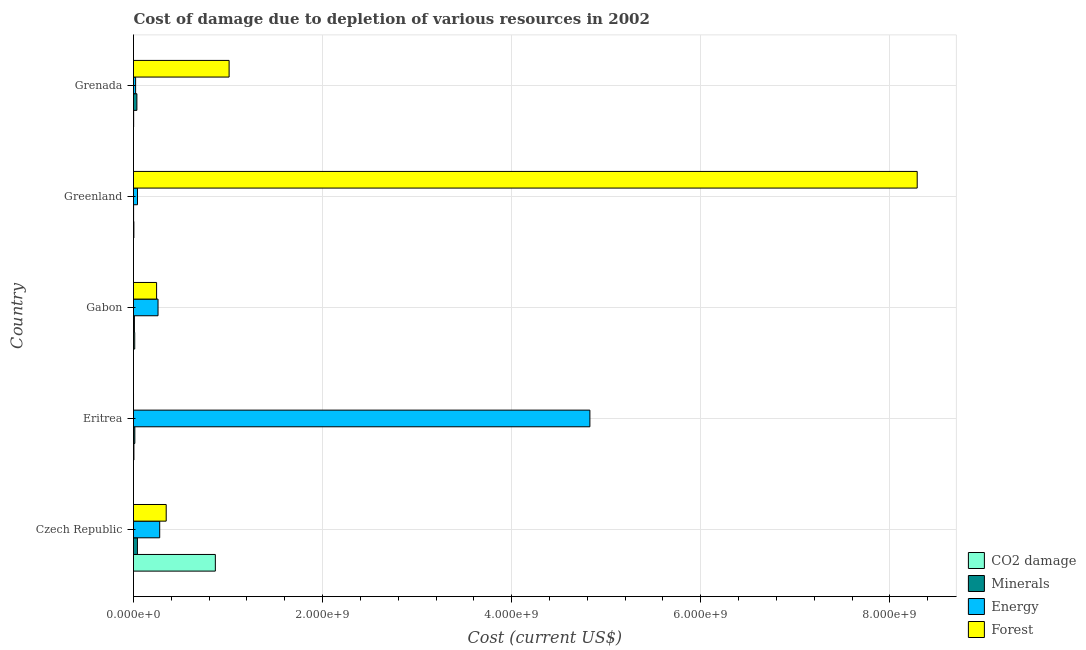How many groups of bars are there?
Provide a short and direct response. 5. Are the number of bars per tick equal to the number of legend labels?
Your answer should be compact. Yes. Are the number of bars on each tick of the Y-axis equal?
Give a very brief answer. Yes. What is the label of the 4th group of bars from the top?
Offer a very short reply. Eritrea. What is the cost of damage due to depletion of energy in Eritrea?
Ensure brevity in your answer.  4.83e+09. Across all countries, what is the maximum cost of damage due to depletion of energy?
Provide a succinct answer. 4.83e+09. Across all countries, what is the minimum cost of damage due to depletion of minerals?
Ensure brevity in your answer.  8.50e+05. In which country was the cost of damage due to depletion of forests maximum?
Your response must be concise. Greenland. In which country was the cost of damage due to depletion of minerals minimum?
Your answer should be compact. Greenland. What is the total cost of damage due to depletion of forests in the graph?
Provide a short and direct response. 9.89e+09. What is the difference between the cost of damage due to depletion of forests in Gabon and that in Grenada?
Offer a very short reply. -7.67e+08. What is the difference between the cost of damage due to depletion of minerals in Grenada and the cost of damage due to depletion of coal in Eritrea?
Your answer should be compact. 3.14e+07. What is the average cost of damage due to depletion of minerals per country?
Give a very brief answer. 2.03e+07. What is the difference between the cost of damage due to depletion of forests and cost of damage due to depletion of minerals in Greenland?
Your answer should be compact. 8.29e+09. What is the ratio of the cost of damage due to depletion of forests in Czech Republic to that in Grenada?
Your answer should be very brief. 0.34. What is the difference between the highest and the second highest cost of damage due to depletion of forests?
Offer a very short reply. 7.28e+09. What is the difference between the highest and the lowest cost of damage due to depletion of forests?
Your answer should be compact. 8.29e+09. In how many countries, is the cost of damage due to depletion of forests greater than the average cost of damage due to depletion of forests taken over all countries?
Keep it short and to the point. 1. Is it the case that in every country, the sum of the cost of damage due to depletion of coal and cost of damage due to depletion of energy is greater than the sum of cost of damage due to depletion of minerals and cost of damage due to depletion of forests?
Give a very brief answer. No. What does the 2nd bar from the top in Eritrea represents?
Your answer should be compact. Energy. What does the 1st bar from the bottom in Czech Republic represents?
Offer a terse response. CO2 damage. How many bars are there?
Give a very brief answer. 20. How many countries are there in the graph?
Provide a short and direct response. 5. Does the graph contain any zero values?
Keep it short and to the point. No. Where does the legend appear in the graph?
Provide a short and direct response. Bottom right. How many legend labels are there?
Offer a terse response. 4. How are the legend labels stacked?
Your answer should be compact. Vertical. What is the title of the graph?
Provide a short and direct response. Cost of damage due to depletion of various resources in 2002 . What is the label or title of the X-axis?
Keep it short and to the point. Cost (current US$). What is the label or title of the Y-axis?
Provide a short and direct response. Country. What is the Cost (current US$) of CO2 damage in Czech Republic?
Provide a short and direct response. 8.66e+08. What is the Cost (current US$) of Minerals in Czech Republic?
Offer a terse response. 4.16e+07. What is the Cost (current US$) of Energy in Czech Republic?
Provide a succinct answer. 2.77e+08. What is the Cost (current US$) in Forest in Czech Republic?
Keep it short and to the point. 3.46e+08. What is the Cost (current US$) of CO2 damage in Eritrea?
Provide a succinct answer. 4.38e+06. What is the Cost (current US$) in Minerals in Eritrea?
Make the answer very short. 1.40e+07. What is the Cost (current US$) in Energy in Eritrea?
Make the answer very short. 4.83e+09. What is the Cost (current US$) in Forest in Eritrea?
Your answer should be compact. 5.57e+04. What is the Cost (current US$) in CO2 damage in Gabon?
Offer a very short reply. 1.29e+07. What is the Cost (current US$) of Minerals in Gabon?
Your response must be concise. 9.37e+06. What is the Cost (current US$) in Energy in Gabon?
Offer a very short reply. 2.59e+08. What is the Cost (current US$) of Forest in Gabon?
Make the answer very short. 2.44e+08. What is the Cost (current US$) in CO2 damage in Greenland?
Make the answer very short. 3.90e+06. What is the Cost (current US$) in Minerals in Greenland?
Offer a terse response. 8.50e+05. What is the Cost (current US$) in Energy in Greenland?
Provide a succinct answer. 4.22e+07. What is the Cost (current US$) of Forest in Greenland?
Offer a terse response. 8.29e+09. What is the Cost (current US$) in CO2 damage in Grenada?
Your response must be concise. 1.49e+06. What is the Cost (current US$) in Minerals in Grenada?
Make the answer very short. 3.57e+07. What is the Cost (current US$) in Energy in Grenada?
Your answer should be compact. 2.23e+07. What is the Cost (current US$) of Forest in Grenada?
Make the answer very short. 1.01e+09. Across all countries, what is the maximum Cost (current US$) of CO2 damage?
Give a very brief answer. 8.66e+08. Across all countries, what is the maximum Cost (current US$) of Minerals?
Give a very brief answer. 4.16e+07. Across all countries, what is the maximum Cost (current US$) of Energy?
Offer a terse response. 4.83e+09. Across all countries, what is the maximum Cost (current US$) of Forest?
Give a very brief answer. 8.29e+09. Across all countries, what is the minimum Cost (current US$) in CO2 damage?
Provide a succinct answer. 1.49e+06. Across all countries, what is the minimum Cost (current US$) of Minerals?
Ensure brevity in your answer.  8.50e+05. Across all countries, what is the minimum Cost (current US$) in Energy?
Provide a succinct answer. 2.23e+07. Across all countries, what is the minimum Cost (current US$) in Forest?
Give a very brief answer. 5.57e+04. What is the total Cost (current US$) of CO2 damage in the graph?
Make the answer very short. 8.88e+08. What is the total Cost (current US$) in Minerals in the graph?
Your answer should be very brief. 1.01e+08. What is the total Cost (current US$) of Energy in the graph?
Your answer should be very brief. 5.43e+09. What is the total Cost (current US$) in Forest in the graph?
Your response must be concise. 9.89e+09. What is the difference between the Cost (current US$) of CO2 damage in Czech Republic and that in Eritrea?
Provide a short and direct response. 8.61e+08. What is the difference between the Cost (current US$) of Minerals in Czech Republic and that in Eritrea?
Provide a short and direct response. 2.76e+07. What is the difference between the Cost (current US$) of Energy in Czech Republic and that in Eritrea?
Make the answer very short. -4.55e+09. What is the difference between the Cost (current US$) of Forest in Czech Republic and that in Eritrea?
Your answer should be compact. 3.46e+08. What is the difference between the Cost (current US$) of CO2 damage in Czech Republic and that in Gabon?
Provide a succinct answer. 8.53e+08. What is the difference between the Cost (current US$) of Minerals in Czech Republic and that in Gabon?
Offer a very short reply. 3.22e+07. What is the difference between the Cost (current US$) in Energy in Czech Republic and that in Gabon?
Ensure brevity in your answer.  1.78e+07. What is the difference between the Cost (current US$) of Forest in Czech Republic and that in Gabon?
Your response must be concise. 1.02e+08. What is the difference between the Cost (current US$) of CO2 damage in Czech Republic and that in Greenland?
Make the answer very short. 8.62e+08. What is the difference between the Cost (current US$) in Minerals in Czech Republic and that in Greenland?
Your answer should be compact. 4.07e+07. What is the difference between the Cost (current US$) in Energy in Czech Republic and that in Greenland?
Your answer should be very brief. 2.35e+08. What is the difference between the Cost (current US$) of Forest in Czech Republic and that in Greenland?
Provide a succinct answer. -7.94e+09. What is the difference between the Cost (current US$) of CO2 damage in Czech Republic and that in Grenada?
Provide a succinct answer. 8.64e+08. What is the difference between the Cost (current US$) in Minerals in Czech Republic and that in Grenada?
Your answer should be compact. 5.83e+06. What is the difference between the Cost (current US$) in Energy in Czech Republic and that in Grenada?
Ensure brevity in your answer.  2.55e+08. What is the difference between the Cost (current US$) in Forest in Czech Republic and that in Grenada?
Provide a succinct answer. -6.65e+08. What is the difference between the Cost (current US$) of CO2 damage in Eritrea and that in Gabon?
Give a very brief answer. -8.50e+06. What is the difference between the Cost (current US$) in Minerals in Eritrea and that in Gabon?
Provide a short and direct response. 4.61e+06. What is the difference between the Cost (current US$) in Energy in Eritrea and that in Gabon?
Give a very brief answer. 4.57e+09. What is the difference between the Cost (current US$) in Forest in Eritrea and that in Gabon?
Your answer should be compact. -2.44e+08. What is the difference between the Cost (current US$) of CO2 damage in Eritrea and that in Greenland?
Keep it short and to the point. 4.78e+05. What is the difference between the Cost (current US$) of Minerals in Eritrea and that in Greenland?
Give a very brief answer. 1.31e+07. What is the difference between the Cost (current US$) of Energy in Eritrea and that in Greenland?
Provide a short and direct response. 4.78e+09. What is the difference between the Cost (current US$) in Forest in Eritrea and that in Greenland?
Ensure brevity in your answer.  -8.29e+09. What is the difference between the Cost (current US$) in CO2 damage in Eritrea and that in Grenada?
Keep it short and to the point. 2.89e+06. What is the difference between the Cost (current US$) of Minerals in Eritrea and that in Grenada?
Make the answer very short. -2.17e+07. What is the difference between the Cost (current US$) of Energy in Eritrea and that in Grenada?
Provide a succinct answer. 4.80e+09. What is the difference between the Cost (current US$) in Forest in Eritrea and that in Grenada?
Offer a very short reply. -1.01e+09. What is the difference between the Cost (current US$) in CO2 damage in Gabon and that in Greenland?
Keep it short and to the point. 8.97e+06. What is the difference between the Cost (current US$) of Minerals in Gabon and that in Greenland?
Your answer should be compact. 8.52e+06. What is the difference between the Cost (current US$) of Energy in Gabon and that in Greenland?
Your answer should be very brief. 2.17e+08. What is the difference between the Cost (current US$) in Forest in Gabon and that in Greenland?
Your response must be concise. -8.04e+09. What is the difference between the Cost (current US$) in CO2 damage in Gabon and that in Grenada?
Give a very brief answer. 1.14e+07. What is the difference between the Cost (current US$) in Minerals in Gabon and that in Grenada?
Your answer should be compact. -2.64e+07. What is the difference between the Cost (current US$) in Energy in Gabon and that in Grenada?
Give a very brief answer. 2.37e+08. What is the difference between the Cost (current US$) of Forest in Gabon and that in Grenada?
Provide a succinct answer. -7.67e+08. What is the difference between the Cost (current US$) of CO2 damage in Greenland and that in Grenada?
Offer a very short reply. 2.42e+06. What is the difference between the Cost (current US$) in Minerals in Greenland and that in Grenada?
Provide a short and direct response. -3.49e+07. What is the difference between the Cost (current US$) of Energy in Greenland and that in Grenada?
Provide a short and direct response. 1.99e+07. What is the difference between the Cost (current US$) in Forest in Greenland and that in Grenada?
Your answer should be compact. 7.28e+09. What is the difference between the Cost (current US$) in CO2 damage in Czech Republic and the Cost (current US$) in Minerals in Eritrea?
Your answer should be very brief. 8.52e+08. What is the difference between the Cost (current US$) of CO2 damage in Czech Republic and the Cost (current US$) of Energy in Eritrea?
Your response must be concise. -3.96e+09. What is the difference between the Cost (current US$) in CO2 damage in Czech Republic and the Cost (current US$) in Forest in Eritrea?
Offer a terse response. 8.66e+08. What is the difference between the Cost (current US$) in Minerals in Czech Republic and the Cost (current US$) in Energy in Eritrea?
Offer a terse response. -4.79e+09. What is the difference between the Cost (current US$) in Minerals in Czech Republic and the Cost (current US$) in Forest in Eritrea?
Give a very brief answer. 4.15e+07. What is the difference between the Cost (current US$) of Energy in Czech Republic and the Cost (current US$) of Forest in Eritrea?
Provide a succinct answer. 2.77e+08. What is the difference between the Cost (current US$) of CO2 damage in Czech Republic and the Cost (current US$) of Minerals in Gabon?
Your answer should be very brief. 8.56e+08. What is the difference between the Cost (current US$) of CO2 damage in Czech Republic and the Cost (current US$) of Energy in Gabon?
Make the answer very short. 6.06e+08. What is the difference between the Cost (current US$) of CO2 damage in Czech Republic and the Cost (current US$) of Forest in Gabon?
Your response must be concise. 6.21e+08. What is the difference between the Cost (current US$) in Minerals in Czech Republic and the Cost (current US$) in Energy in Gabon?
Make the answer very short. -2.18e+08. What is the difference between the Cost (current US$) of Minerals in Czech Republic and the Cost (current US$) of Forest in Gabon?
Provide a succinct answer. -2.03e+08. What is the difference between the Cost (current US$) in Energy in Czech Republic and the Cost (current US$) in Forest in Gabon?
Keep it short and to the point. 3.29e+07. What is the difference between the Cost (current US$) of CO2 damage in Czech Republic and the Cost (current US$) of Minerals in Greenland?
Your answer should be compact. 8.65e+08. What is the difference between the Cost (current US$) in CO2 damage in Czech Republic and the Cost (current US$) in Energy in Greenland?
Ensure brevity in your answer.  8.23e+08. What is the difference between the Cost (current US$) of CO2 damage in Czech Republic and the Cost (current US$) of Forest in Greenland?
Give a very brief answer. -7.42e+09. What is the difference between the Cost (current US$) in Minerals in Czech Republic and the Cost (current US$) in Energy in Greenland?
Provide a short and direct response. -6.05e+05. What is the difference between the Cost (current US$) in Minerals in Czech Republic and the Cost (current US$) in Forest in Greenland?
Provide a succinct answer. -8.25e+09. What is the difference between the Cost (current US$) in Energy in Czech Republic and the Cost (current US$) in Forest in Greenland?
Make the answer very short. -8.01e+09. What is the difference between the Cost (current US$) in CO2 damage in Czech Republic and the Cost (current US$) in Minerals in Grenada?
Your answer should be very brief. 8.30e+08. What is the difference between the Cost (current US$) in CO2 damage in Czech Republic and the Cost (current US$) in Energy in Grenada?
Make the answer very short. 8.43e+08. What is the difference between the Cost (current US$) in CO2 damage in Czech Republic and the Cost (current US$) in Forest in Grenada?
Your response must be concise. -1.46e+08. What is the difference between the Cost (current US$) of Minerals in Czech Republic and the Cost (current US$) of Energy in Grenada?
Keep it short and to the point. 1.93e+07. What is the difference between the Cost (current US$) of Minerals in Czech Republic and the Cost (current US$) of Forest in Grenada?
Keep it short and to the point. -9.70e+08. What is the difference between the Cost (current US$) of Energy in Czech Republic and the Cost (current US$) of Forest in Grenada?
Offer a very short reply. -7.34e+08. What is the difference between the Cost (current US$) of CO2 damage in Eritrea and the Cost (current US$) of Minerals in Gabon?
Offer a very short reply. -4.99e+06. What is the difference between the Cost (current US$) in CO2 damage in Eritrea and the Cost (current US$) in Energy in Gabon?
Your answer should be compact. -2.55e+08. What is the difference between the Cost (current US$) in CO2 damage in Eritrea and the Cost (current US$) in Forest in Gabon?
Your response must be concise. -2.40e+08. What is the difference between the Cost (current US$) of Minerals in Eritrea and the Cost (current US$) of Energy in Gabon?
Make the answer very short. -2.45e+08. What is the difference between the Cost (current US$) in Minerals in Eritrea and the Cost (current US$) in Forest in Gabon?
Ensure brevity in your answer.  -2.30e+08. What is the difference between the Cost (current US$) of Energy in Eritrea and the Cost (current US$) of Forest in Gabon?
Provide a succinct answer. 4.58e+09. What is the difference between the Cost (current US$) of CO2 damage in Eritrea and the Cost (current US$) of Minerals in Greenland?
Make the answer very short. 3.53e+06. What is the difference between the Cost (current US$) in CO2 damage in Eritrea and the Cost (current US$) in Energy in Greenland?
Your answer should be very brief. -3.78e+07. What is the difference between the Cost (current US$) of CO2 damage in Eritrea and the Cost (current US$) of Forest in Greenland?
Keep it short and to the point. -8.28e+09. What is the difference between the Cost (current US$) of Minerals in Eritrea and the Cost (current US$) of Energy in Greenland?
Your answer should be very brief. -2.82e+07. What is the difference between the Cost (current US$) in Minerals in Eritrea and the Cost (current US$) in Forest in Greenland?
Your response must be concise. -8.28e+09. What is the difference between the Cost (current US$) in Energy in Eritrea and the Cost (current US$) in Forest in Greenland?
Your response must be concise. -3.46e+09. What is the difference between the Cost (current US$) in CO2 damage in Eritrea and the Cost (current US$) in Minerals in Grenada?
Give a very brief answer. -3.14e+07. What is the difference between the Cost (current US$) in CO2 damage in Eritrea and the Cost (current US$) in Energy in Grenada?
Give a very brief answer. -1.79e+07. What is the difference between the Cost (current US$) of CO2 damage in Eritrea and the Cost (current US$) of Forest in Grenada?
Give a very brief answer. -1.01e+09. What is the difference between the Cost (current US$) in Minerals in Eritrea and the Cost (current US$) in Energy in Grenada?
Ensure brevity in your answer.  -8.31e+06. What is the difference between the Cost (current US$) of Minerals in Eritrea and the Cost (current US$) of Forest in Grenada?
Offer a very short reply. -9.97e+08. What is the difference between the Cost (current US$) in Energy in Eritrea and the Cost (current US$) in Forest in Grenada?
Offer a terse response. 3.82e+09. What is the difference between the Cost (current US$) in CO2 damage in Gabon and the Cost (current US$) in Minerals in Greenland?
Keep it short and to the point. 1.20e+07. What is the difference between the Cost (current US$) of CO2 damage in Gabon and the Cost (current US$) of Energy in Greenland?
Your response must be concise. -2.93e+07. What is the difference between the Cost (current US$) of CO2 damage in Gabon and the Cost (current US$) of Forest in Greenland?
Ensure brevity in your answer.  -8.28e+09. What is the difference between the Cost (current US$) in Minerals in Gabon and the Cost (current US$) in Energy in Greenland?
Offer a very short reply. -3.28e+07. What is the difference between the Cost (current US$) of Minerals in Gabon and the Cost (current US$) of Forest in Greenland?
Offer a terse response. -8.28e+09. What is the difference between the Cost (current US$) in Energy in Gabon and the Cost (current US$) in Forest in Greenland?
Provide a short and direct response. -8.03e+09. What is the difference between the Cost (current US$) in CO2 damage in Gabon and the Cost (current US$) in Minerals in Grenada?
Offer a very short reply. -2.29e+07. What is the difference between the Cost (current US$) of CO2 damage in Gabon and the Cost (current US$) of Energy in Grenada?
Keep it short and to the point. -9.42e+06. What is the difference between the Cost (current US$) of CO2 damage in Gabon and the Cost (current US$) of Forest in Grenada?
Ensure brevity in your answer.  -9.98e+08. What is the difference between the Cost (current US$) in Minerals in Gabon and the Cost (current US$) in Energy in Grenada?
Give a very brief answer. -1.29e+07. What is the difference between the Cost (current US$) of Minerals in Gabon and the Cost (current US$) of Forest in Grenada?
Make the answer very short. -1.00e+09. What is the difference between the Cost (current US$) in Energy in Gabon and the Cost (current US$) in Forest in Grenada?
Make the answer very short. -7.52e+08. What is the difference between the Cost (current US$) in CO2 damage in Greenland and the Cost (current US$) in Minerals in Grenada?
Your answer should be very brief. -3.18e+07. What is the difference between the Cost (current US$) in CO2 damage in Greenland and the Cost (current US$) in Energy in Grenada?
Provide a short and direct response. -1.84e+07. What is the difference between the Cost (current US$) in CO2 damage in Greenland and the Cost (current US$) in Forest in Grenada?
Offer a very short reply. -1.01e+09. What is the difference between the Cost (current US$) of Minerals in Greenland and the Cost (current US$) of Energy in Grenada?
Offer a terse response. -2.14e+07. What is the difference between the Cost (current US$) in Minerals in Greenland and the Cost (current US$) in Forest in Grenada?
Your answer should be compact. -1.01e+09. What is the difference between the Cost (current US$) in Energy in Greenland and the Cost (current US$) in Forest in Grenada?
Give a very brief answer. -9.69e+08. What is the average Cost (current US$) in CO2 damage per country?
Your answer should be compact. 1.78e+08. What is the average Cost (current US$) in Minerals per country?
Ensure brevity in your answer.  2.03e+07. What is the average Cost (current US$) of Energy per country?
Offer a terse response. 1.09e+09. What is the average Cost (current US$) in Forest per country?
Your response must be concise. 1.98e+09. What is the difference between the Cost (current US$) of CO2 damage and Cost (current US$) of Minerals in Czech Republic?
Offer a terse response. 8.24e+08. What is the difference between the Cost (current US$) in CO2 damage and Cost (current US$) in Energy in Czech Republic?
Keep it short and to the point. 5.88e+08. What is the difference between the Cost (current US$) in CO2 damage and Cost (current US$) in Forest in Czech Republic?
Make the answer very short. 5.20e+08. What is the difference between the Cost (current US$) in Minerals and Cost (current US$) in Energy in Czech Republic?
Make the answer very short. -2.36e+08. What is the difference between the Cost (current US$) in Minerals and Cost (current US$) in Forest in Czech Republic?
Give a very brief answer. -3.04e+08. What is the difference between the Cost (current US$) of Energy and Cost (current US$) of Forest in Czech Republic?
Offer a very short reply. -6.87e+07. What is the difference between the Cost (current US$) in CO2 damage and Cost (current US$) in Minerals in Eritrea?
Offer a very short reply. -9.60e+06. What is the difference between the Cost (current US$) in CO2 damage and Cost (current US$) in Energy in Eritrea?
Make the answer very short. -4.82e+09. What is the difference between the Cost (current US$) in CO2 damage and Cost (current US$) in Forest in Eritrea?
Ensure brevity in your answer.  4.33e+06. What is the difference between the Cost (current US$) in Minerals and Cost (current US$) in Energy in Eritrea?
Offer a very short reply. -4.81e+09. What is the difference between the Cost (current US$) in Minerals and Cost (current US$) in Forest in Eritrea?
Make the answer very short. 1.39e+07. What is the difference between the Cost (current US$) of Energy and Cost (current US$) of Forest in Eritrea?
Provide a succinct answer. 4.83e+09. What is the difference between the Cost (current US$) in CO2 damage and Cost (current US$) in Minerals in Gabon?
Your response must be concise. 3.50e+06. What is the difference between the Cost (current US$) of CO2 damage and Cost (current US$) of Energy in Gabon?
Provide a short and direct response. -2.46e+08. What is the difference between the Cost (current US$) of CO2 damage and Cost (current US$) of Forest in Gabon?
Offer a terse response. -2.31e+08. What is the difference between the Cost (current US$) in Minerals and Cost (current US$) in Energy in Gabon?
Offer a very short reply. -2.50e+08. What is the difference between the Cost (current US$) in Minerals and Cost (current US$) in Forest in Gabon?
Your answer should be compact. -2.35e+08. What is the difference between the Cost (current US$) in Energy and Cost (current US$) in Forest in Gabon?
Keep it short and to the point. 1.51e+07. What is the difference between the Cost (current US$) in CO2 damage and Cost (current US$) in Minerals in Greenland?
Make the answer very short. 3.05e+06. What is the difference between the Cost (current US$) of CO2 damage and Cost (current US$) of Energy in Greenland?
Your answer should be very brief. -3.83e+07. What is the difference between the Cost (current US$) in CO2 damage and Cost (current US$) in Forest in Greenland?
Your answer should be very brief. -8.29e+09. What is the difference between the Cost (current US$) in Minerals and Cost (current US$) in Energy in Greenland?
Provide a succinct answer. -4.13e+07. What is the difference between the Cost (current US$) in Minerals and Cost (current US$) in Forest in Greenland?
Keep it short and to the point. -8.29e+09. What is the difference between the Cost (current US$) in Energy and Cost (current US$) in Forest in Greenland?
Provide a short and direct response. -8.25e+09. What is the difference between the Cost (current US$) in CO2 damage and Cost (current US$) in Minerals in Grenada?
Make the answer very short. -3.42e+07. What is the difference between the Cost (current US$) in CO2 damage and Cost (current US$) in Energy in Grenada?
Provide a succinct answer. -2.08e+07. What is the difference between the Cost (current US$) in CO2 damage and Cost (current US$) in Forest in Grenada?
Offer a very short reply. -1.01e+09. What is the difference between the Cost (current US$) in Minerals and Cost (current US$) in Energy in Grenada?
Your answer should be very brief. 1.34e+07. What is the difference between the Cost (current US$) in Minerals and Cost (current US$) in Forest in Grenada?
Give a very brief answer. -9.75e+08. What is the difference between the Cost (current US$) in Energy and Cost (current US$) in Forest in Grenada?
Make the answer very short. -9.89e+08. What is the ratio of the Cost (current US$) in CO2 damage in Czech Republic to that in Eritrea?
Give a very brief answer. 197.59. What is the ratio of the Cost (current US$) in Minerals in Czech Republic to that in Eritrea?
Your answer should be very brief. 2.97. What is the ratio of the Cost (current US$) of Energy in Czech Republic to that in Eritrea?
Provide a short and direct response. 0.06. What is the ratio of the Cost (current US$) in Forest in Czech Republic to that in Eritrea?
Make the answer very short. 6212.26. What is the ratio of the Cost (current US$) in CO2 damage in Czech Republic to that in Gabon?
Your answer should be very brief. 67.22. What is the ratio of the Cost (current US$) of Minerals in Czech Republic to that in Gabon?
Give a very brief answer. 4.43. What is the ratio of the Cost (current US$) of Energy in Czech Republic to that in Gabon?
Keep it short and to the point. 1.07. What is the ratio of the Cost (current US$) of Forest in Czech Republic to that in Gabon?
Keep it short and to the point. 1.42. What is the ratio of the Cost (current US$) in CO2 damage in Czech Republic to that in Greenland?
Offer a terse response. 221.78. What is the ratio of the Cost (current US$) of Minerals in Czech Republic to that in Greenland?
Your answer should be compact. 48.91. What is the ratio of the Cost (current US$) of Energy in Czech Republic to that in Greenland?
Your response must be concise. 6.57. What is the ratio of the Cost (current US$) in Forest in Czech Republic to that in Greenland?
Provide a succinct answer. 0.04. What is the ratio of the Cost (current US$) in CO2 damage in Czech Republic to that in Grenada?
Keep it short and to the point. 582.18. What is the ratio of the Cost (current US$) of Minerals in Czech Republic to that in Grenada?
Offer a terse response. 1.16. What is the ratio of the Cost (current US$) in Energy in Czech Republic to that in Grenada?
Your answer should be very brief. 12.43. What is the ratio of the Cost (current US$) in Forest in Czech Republic to that in Grenada?
Your response must be concise. 0.34. What is the ratio of the Cost (current US$) of CO2 damage in Eritrea to that in Gabon?
Your response must be concise. 0.34. What is the ratio of the Cost (current US$) in Minerals in Eritrea to that in Gabon?
Your answer should be compact. 1.49. What is the ratio of the Cost (current US$) of Energy in Eritrea to that in Gabon?
Keep it short and to the point. 18.62. What is the ratio of the Cost (current US$) in CO2 damage in Eritrea to that in Greenland?
Your answer should be very brief. 1.12. What is the ratio of the Cost (current US$) in Minerals in Eritrea to that in Greenland?
Keep it short and to the point. 16.46. What is the ratio of the Cost (current US$) in Energy in Eritrea to that in Greenland?
Give a very brief answer. 114.49. What is the ratio of the Cost (current US$) in Forest in Eritrea to that in Greenland?
Offer a very short reply. 0. What is the ratio of the Cost (current US$) in CO2 damage in Eritrea to that in Grenada?
Offer a terse response. 2.95. What is the ratio of the Cost (current US$) in Minerals in Eritrea to that in Grenada?
Your answer should be compact. 0.39. What is the ratio of the Cost (current US$) of Energy in Eritrea to that in Grenada?
Keep it short and to the point. 216.48. What is the ratio of the Cost (current US$) of CO2 damage in Gabon to that in Greenland?
Make the answer very short. 3.3. What is the ratio of the Cost (current US$) in Minerals in Gabon to that in Greenland?
Offer a very short reply. 11.03. What is the ratio of the Cost (current US$) in Energy in Gabon to that in Greenland?
Give a very brief answer. 6.15. What is the ratio of the Cost (current US$) in Forest in Gabon to that in Greenland?
Offer a very short reply. 0.03. What is the ratio of the Cost (current US$) of CO2 damage in Gabon to that in Grenada?
Offer a terse response. 8.66. What is the ratio of the Cost (current US$) of Minerals in Gabon to that in Grenada?
Provide a short and direct response. 0.26. What is the ratio of the Cost (current US$) of Energy in Gabon to that in Grenada?
Your response must be concise. 11.63. What is the ratio of the Cost (current US$) of Forest in Gabon to that in Grenada?
Your answer should be very brief. 0.24. What is the ratio of the Cost (current US$) in CO2 damage in Greenland to that in Grenada?
Offer a very short reply. 2.62. What is the ratio of the Cost (current US$) of Minerals in Greenland to that in Grenada?
Provide a short and direct response. 0.02. What is the ratio of the Cost (current US$) in Energy in Greenland to that in Grenada?
Give a very brief answer. 1.89. What is the ratio of the Cost (current US$) of Forest in Greenland to that in Grenada?
Offer a very short reply. 8.2. What is the difference between the highest and the second highest Cost (current US$) in CO2 damage?
Your answer should be compact. 8.53e+08. What is the difference between the highest and the second highest Cost (current US$) of Minerals?
Provide a short and direct response. 5.83e+06. What is the difference between the highest and the second highest Cost (current US$) of Energy?
Offer a terse response. 4.55e+09. What is the difference between the highest and the second highest Cost (current US$) in Forest?
Give a very brief answer. 7.28e+09. What is the difference between the highest and the lowest Cost (current US$) in CO2 damage?
Ensure brevity in your answer.  8.64e+08. What is the difference between the highest and the lowest Cost (current US$) of Minerals?
Your answer should be very brief. 4.07e+07. What is the difference between the highest and the lowest Cost (current US$) of Energy?
Your answer should be compact. 4.80e+09. What is the difference between the highest and the lowest Cost (current US$) in Forest?
Your answer should be very brief. 8.29e+09. 